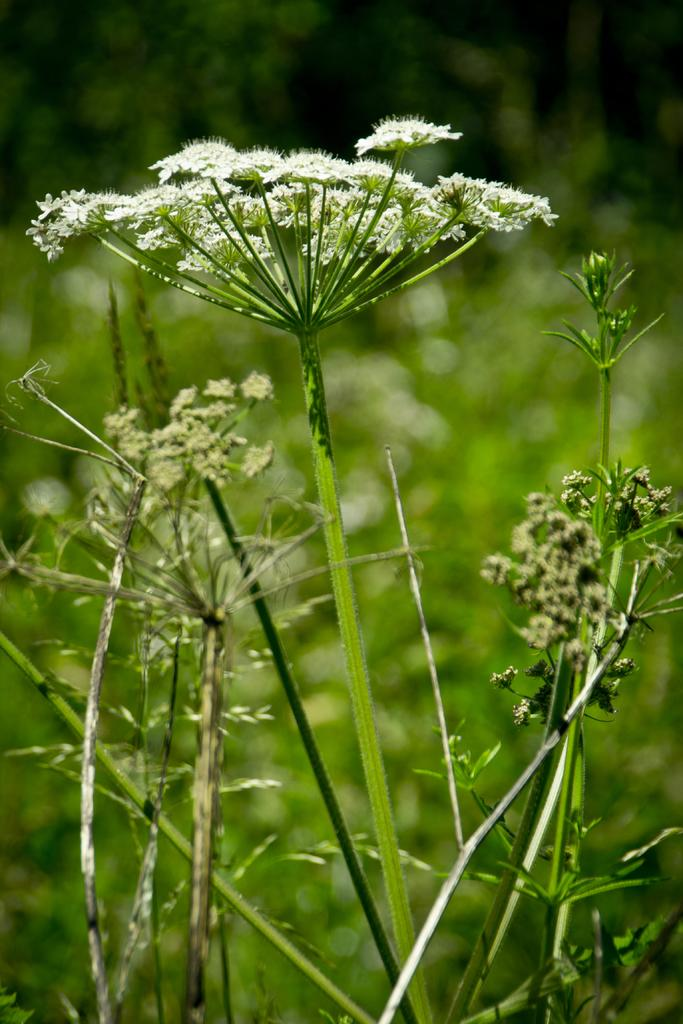What type of living organisms can be seen in the image? Plants can be seen in the image. Can you describe the background of the image? The background of the image is blurred. What type of zipper can be seen on the plants in the image? There is no zipper present on the plants in the image. What type of club is visible in the image? There is no club present in the image. 